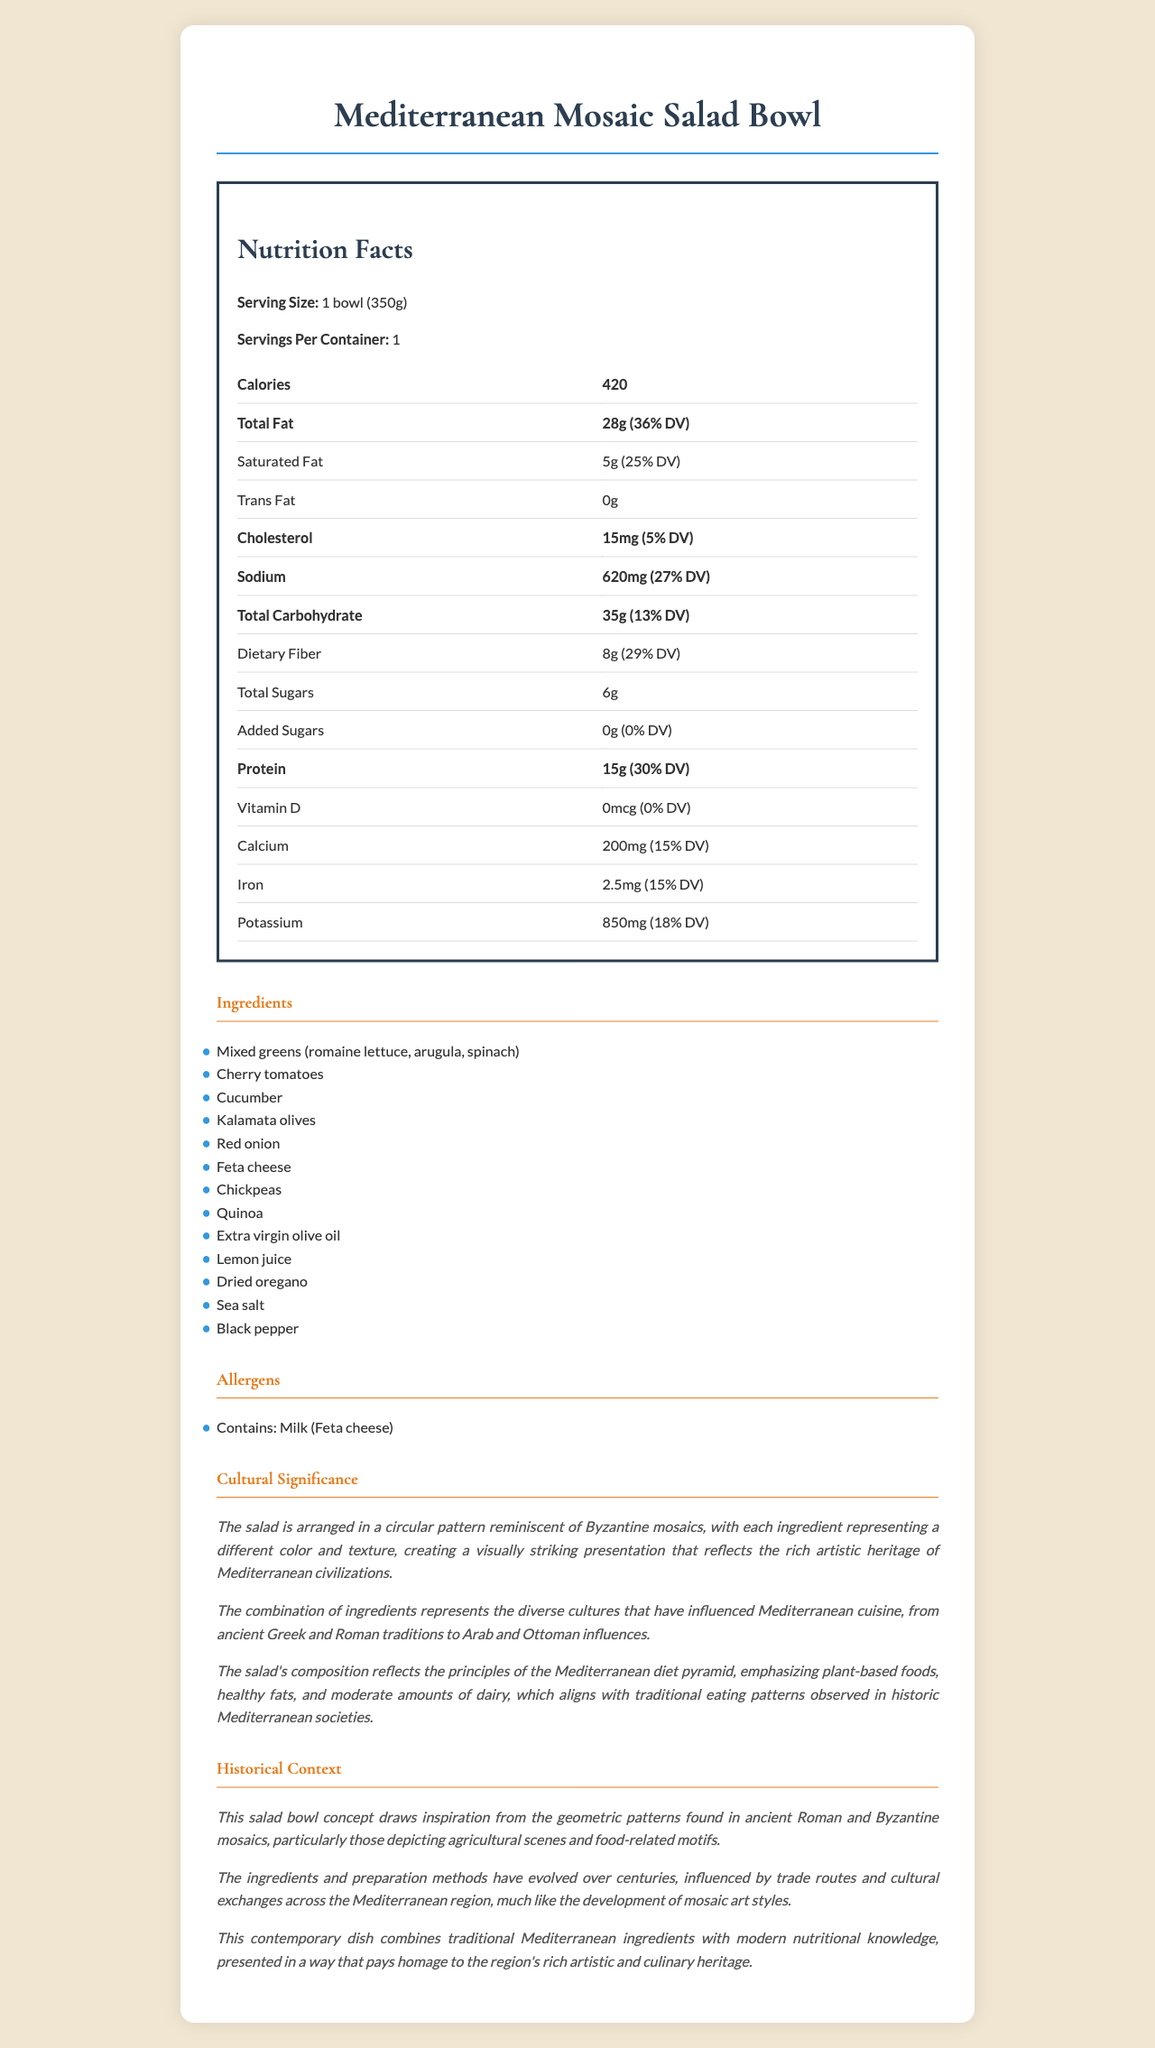what is the serving size of the Mediterranean Mosaic Salad Bowl? The serving size is explicitly mentioned as "1 bowl (350g)" in the Nutrition Facts section.
Answer: 1 bowl (350g) how many calories are in one serving of the Mediterranean Mosaic Salad Bowl? The calories per serving are listed as 420 in the Nutrition Facts section.
Answer: 420 what is the amount of total fat in the salad? The total fat amount is shown as 28g in the Nutrition Facts section.
Answer: 28g how much protein does the salad contain? The protein content is listed as 15g in the Nutrition Facts section.
Answer: 15g what is the daily value percentage of dietary fiber in the salad? The daily value percentage of dietary fiber is indicated as 29% in the Nutrition Facts section.
Answer: 29% which ingredient is a significant allergen in the salad? A. Chickpeas B. Olive oil C. Feta cheese D. Kalamata olives The allergens section of the document specifies "Contains: Milk (Feta cheese)".
Answer: C how much calcium is in the salad? The amount of calcium is listed as 200mg in the Nutrition Facts section.
Answer: 200mg what type of design patterns does the salad arrangement resemble? The cultural significance section mentions that the salad is arranged in a circular pattern reminiscent of Byzantine mosaics.
Answer: Byzantine mosaics which civilizations influenced the combination of ingredients in the salad? A. Ancient Greek and Roman B. Arab and Ottoman C. Both A and B D. Celtic and Norse The cultural significance section notes that the combination of ingredients represents influences from both ancient Greek and Roman traditions as well as Arab and Ottoman influences.
Answer: C is added sugar present in the salad? The amount of added sugars is shown as 0g in the Nutrition Facts section.
Answer: No how has the preparation of the salad evolved over time? The historical context section details that the ingredients and preparation methods have evolved over centuries due to trade routes and cultural exchanges across the Mediterranean.
Answer: Influenced by trade routes and cultural exchanges summarize the main idea of the document. The document provides detailed nutritional information, lists ingredients and allergens, and explains the cultural and historical significance of the salad. It highlights the mosaic-like design and the diversity of ingredients influenced by Mediterranean civilizations.
Answer: Presentation and nutritional information about the Mediterranean Mosaic Salad Bowl, highlighting its cultural and historical significance. what is the vitamin D content in the salad? The document lists vitamin D content as 0mcg but doesn't clarify if any amount of vitamin D is not mentioned due to the absence in the salad or a broader context about its source.
Answer: Cannot be determined 